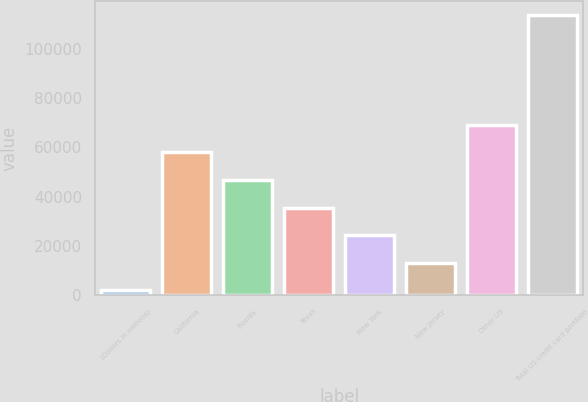<chart> <loc_0><loc_0><loc_500><loc_500><bar_chart><fcel>(Dollars in millions)<fcel>California<fcel>Florida<fcel>Texas<fcel>New York<fcel>New Jersey<fcel>Other US<fcel>Total US credit card portfolio<nl><fcel>2010<fcel>57897.5<fcel>46720<fcel>35542.5<fcel>24365<fcel>13187.5<fcel>69075<fcel>113785<nl></chart> 